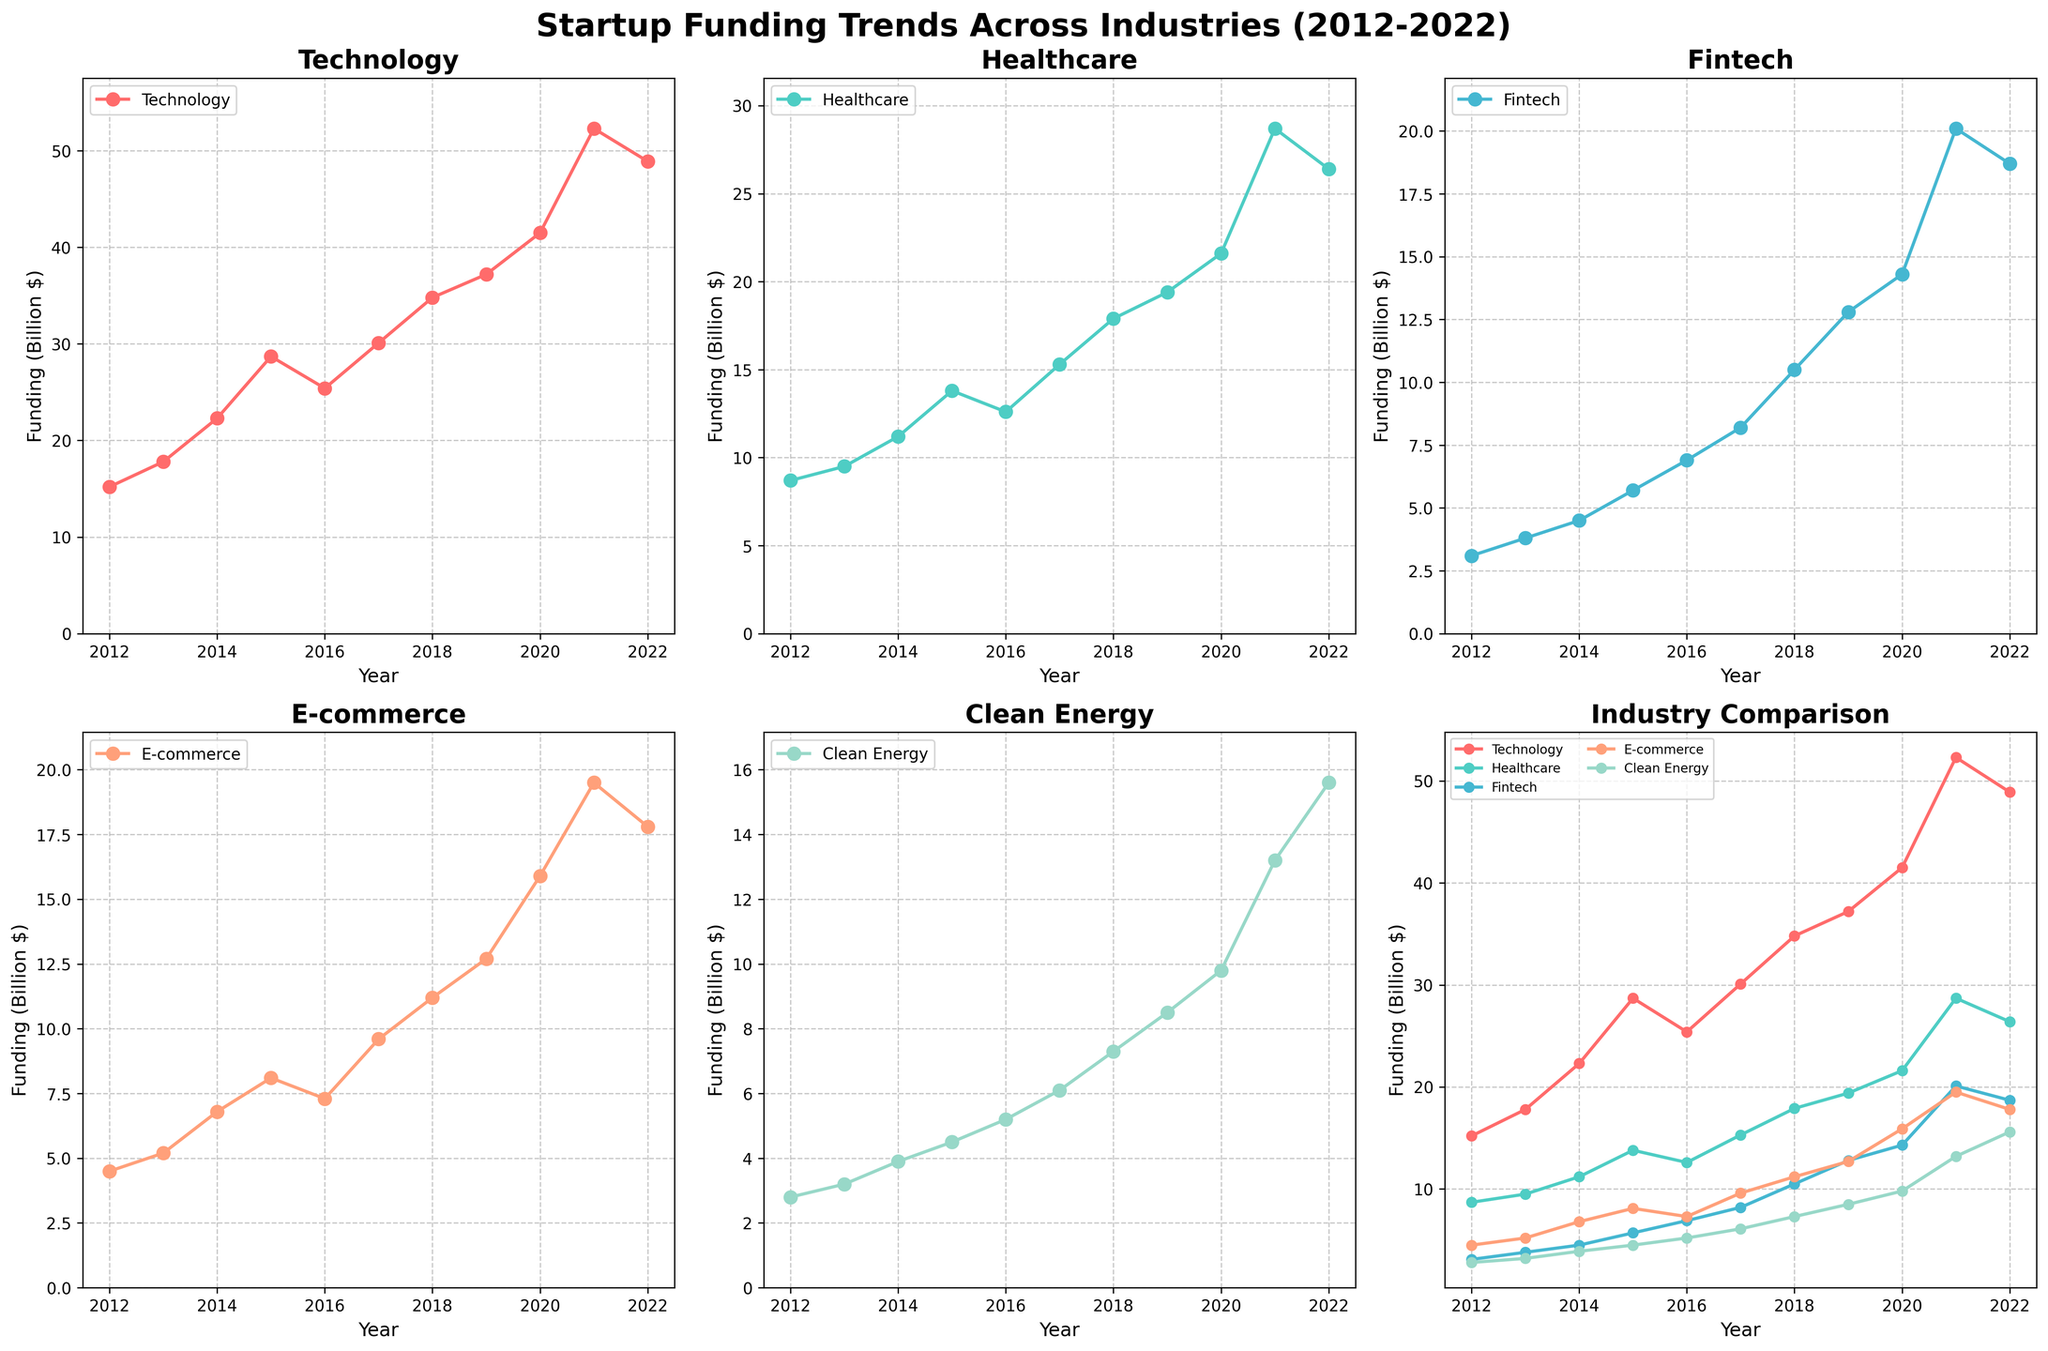What was the funding for Healthcare in 2014? From the Healthcare subplot or the comparison subplot, locate the point corresponding to the year 2014. The funding level for Healthcare at that point is 11.2 billion dollars.
Answer: 11.2 billion dollars Which industry had the highest funding amount in 2021? Look at the comparison subplot for the year 2021 and compare the heights of the funding points across all industries. Technology had the highest funding of 52.3 billion dollars in 2021.
Answer: Technology How much did the funding in Technology increase from 2012 to 2020? Identify the data points of Technology for the years 2012 and 2020. The funding levels are 15.2 billion dollars in 2012 and 41.5 billion dollars in 2020. The increase is 41.5 - 15.2 = 26.3 billion dollars.
Answer: 26.3 billion dollars By how much did Clean Energy funding grow on average per year from 2012 to 2022? The total growth over the 10-year period for Clean Energy funding is from 2.8 billion dollars in 2012 to 15.6 billion dollars in 2022. The average annual growth is (15.6 - 2.8) / 10 = 1.28 billion dollars per year.
Answer: 1.28 billion dollars per year Which industry showed the most consistent growth over the past decade? Examine the shape and trend of the funding lines in each subplot. Consistent growth implies a steady and relatively linear increase without dramatic fluctuations. Healthcare shows a steady increase in the funding line from 2012 to 2022.
Answer: Healthcare In which year did Fintech funding first surpass 10 billion dollars? Look at the Fintech subplot to find when the funding crossed the 10 billion dollar mark. The first point above 10 billion is in 2018, where the funding was 10.5 billion dollars.
Answer: 2018 What is the total funding for all industries in 2015? Sum up the individual funding values for all industries in 2015. The values are 28.7 (Technology) + 13.8 (Healthcare) + 5.7 (Fintech) + 8.1 (E-commerce) + 4.5 (Clean Energy). The total funding is 60.8 billion dollars.
Answer: 60.8 billion dollars Compare the growth in funding between E-commerce and Fintech from 2017 to 2021. Which grew more? Calculate the funding growth for both industries from 2017 to 2021. E-commerce grew from 9.6 billion dollars in 2017 to 19.5 billion dollars in 2021, a growth of 9.9 billion dollars. Fintech grew from 8.2 billion dollars in 2017 to 20.1 billion dollars in 2021, a growth of 11.9 billion dollars. Therefore, Fintech grew more.
Answer: Fintech 